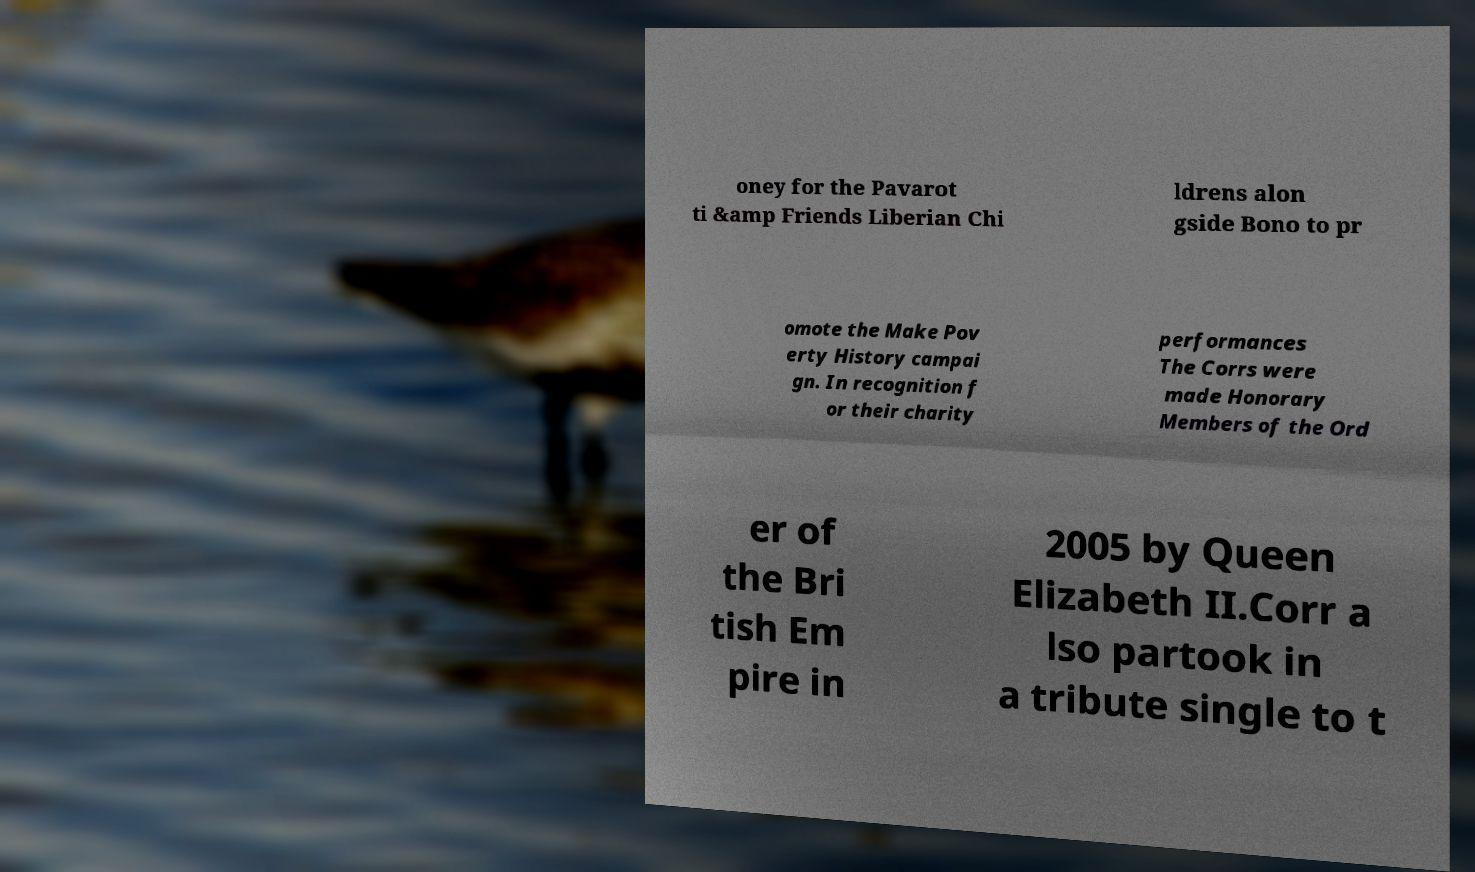I need the written content from this picture converted into text. Can you do that? oney for the Pavarot ti &amp Friends Liberian Chi ldrens alon gside Bono to pr omote the Make Pov erty History campai gn. In recognition f or their charity performances The Corrs were made Honorary Members of the Ord er of the Bri tish Em pire in 2005 by Queen Elizabeth II.Corr a lso partook in a tribute single to t 